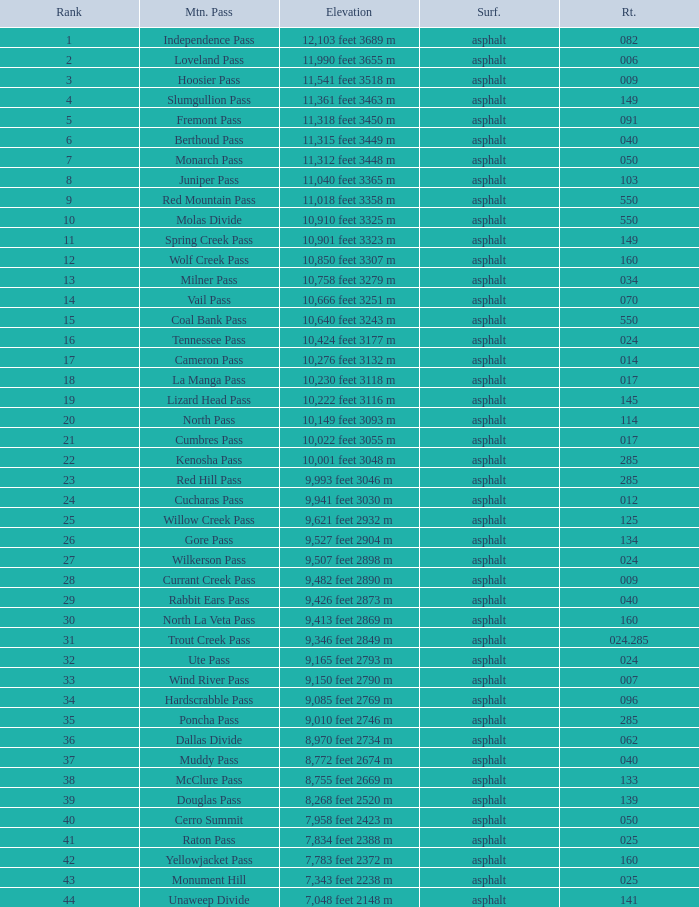On what Route is the mountain with a Rank less than 33 and an Elevation of 11,312 feet 3448 m? 50.0. 